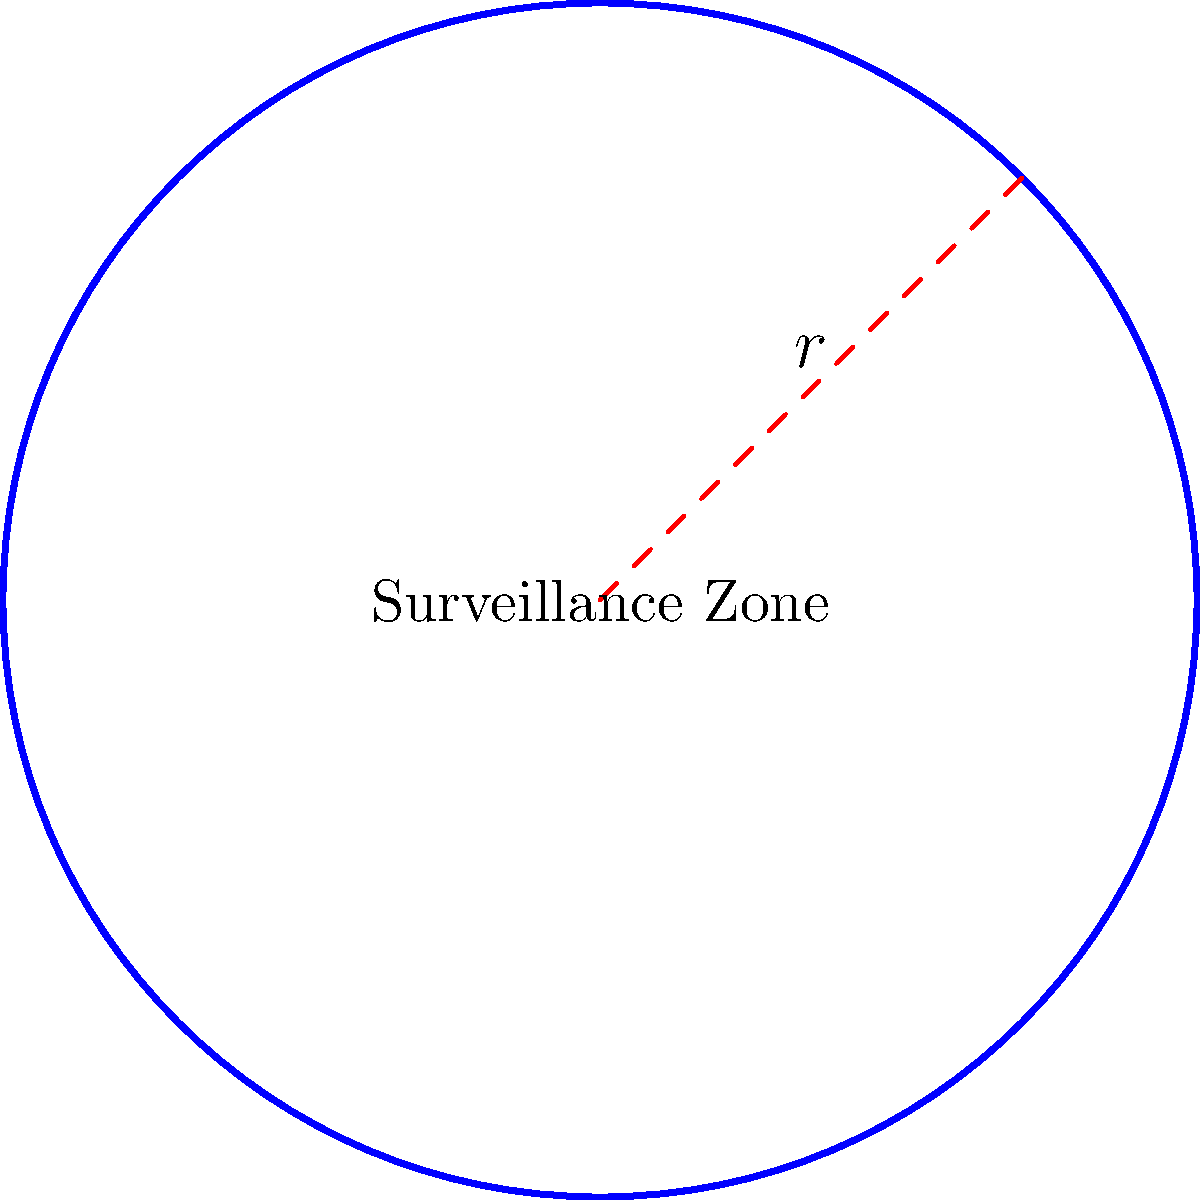In a high-profile case, you need to establish a circular surveillance zone around a crime scene. If the radius of this zone is 300 meters, what is the perimeter of the area that needs to be monitored? To solve this problem, we need to follow these steps:

1) The formula for the circumference (perimeter) of a circle is:
   $$C = 2\pi r$$
   where $C$ is the circumference, $\pi$ is pi (approximately 3.14159), and $r$ is the radius.

2) We are given that the radius $r = 300$ meters.

3) Let's substitute these values into our formula:
   $$C = 2\pi(300)$$

4) We can simplify this:
   $$C = 600\pi$$

5) If we want to calculate the exact value, we can use the full value of pi:
   $$C = 600 * 3.14159... \approx 1884.96 \text{ meters}$$

6) Rounding to the nearest meter, we get 1885 meters.
Answer: 1885 meters 